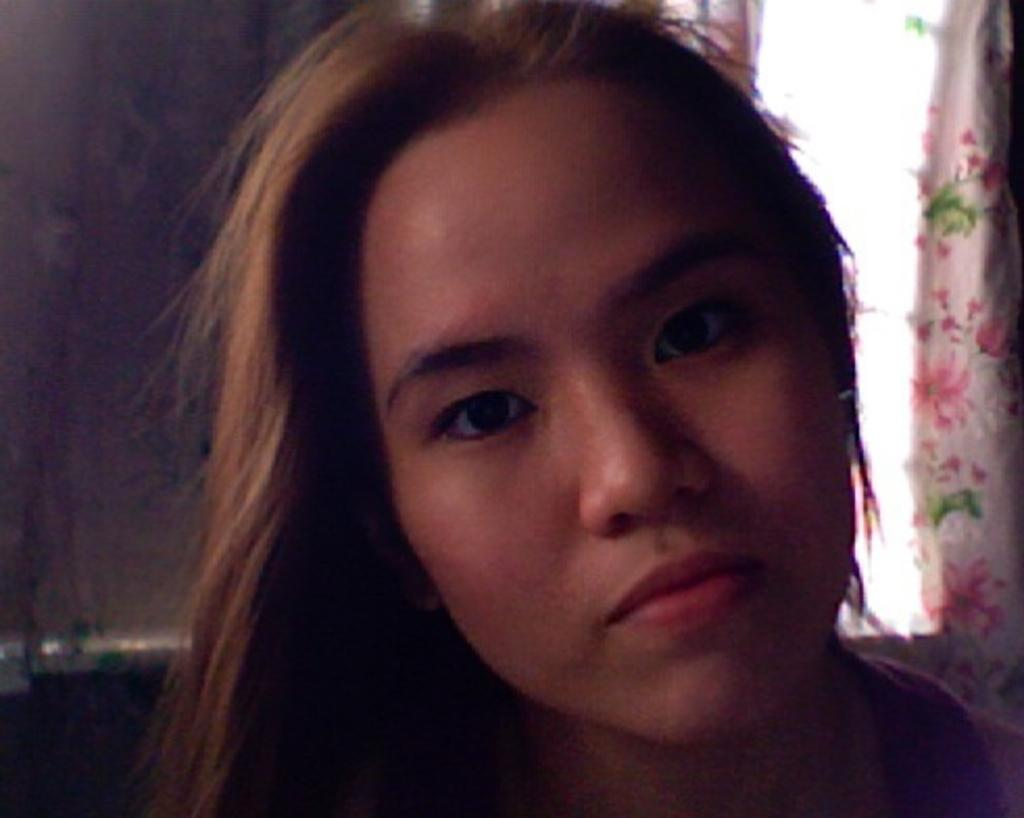What is the main subject of the image? The main subject of the image is a woman. Can you describe the background or setting of the image? There is a curtain present behind the woman. What type of quince is the woman holding in the image? There is no quince present in the image, and the woman is not holding anything. 